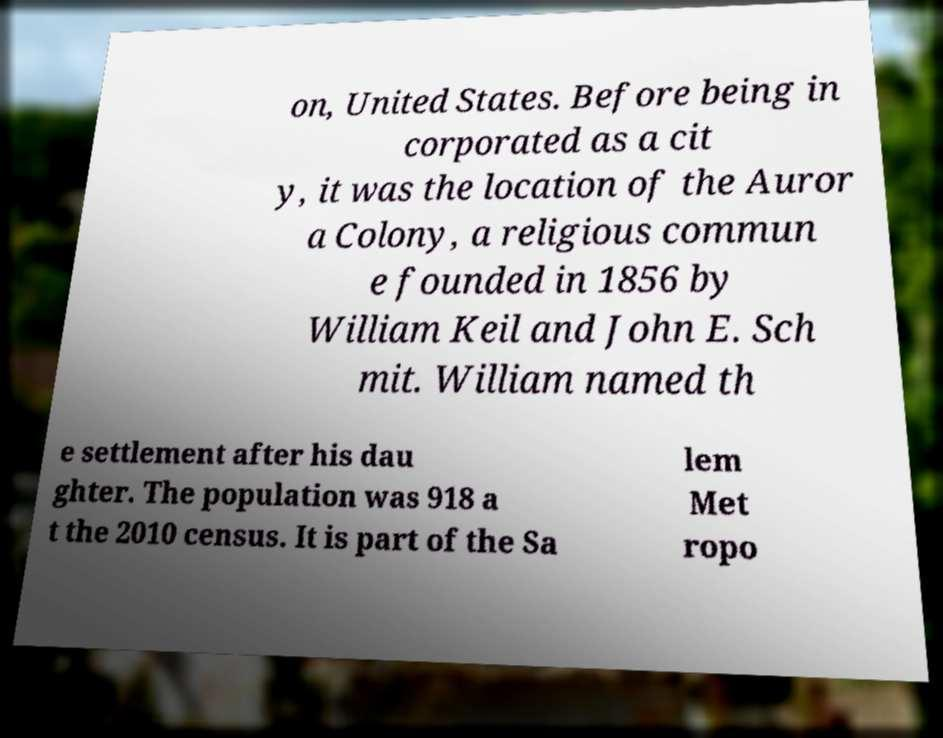Could you extract and type out the text from this image? on, United States. Before being in corporated as a cit y, it was the location of the Auror a Colony, a religious commun e founded in 1856 by William Keil and John E. Sch mit. William named th e settlement after his dau ghter. The population was 918 a t the 2010 census. It is part of the Sa lem Met ropo 